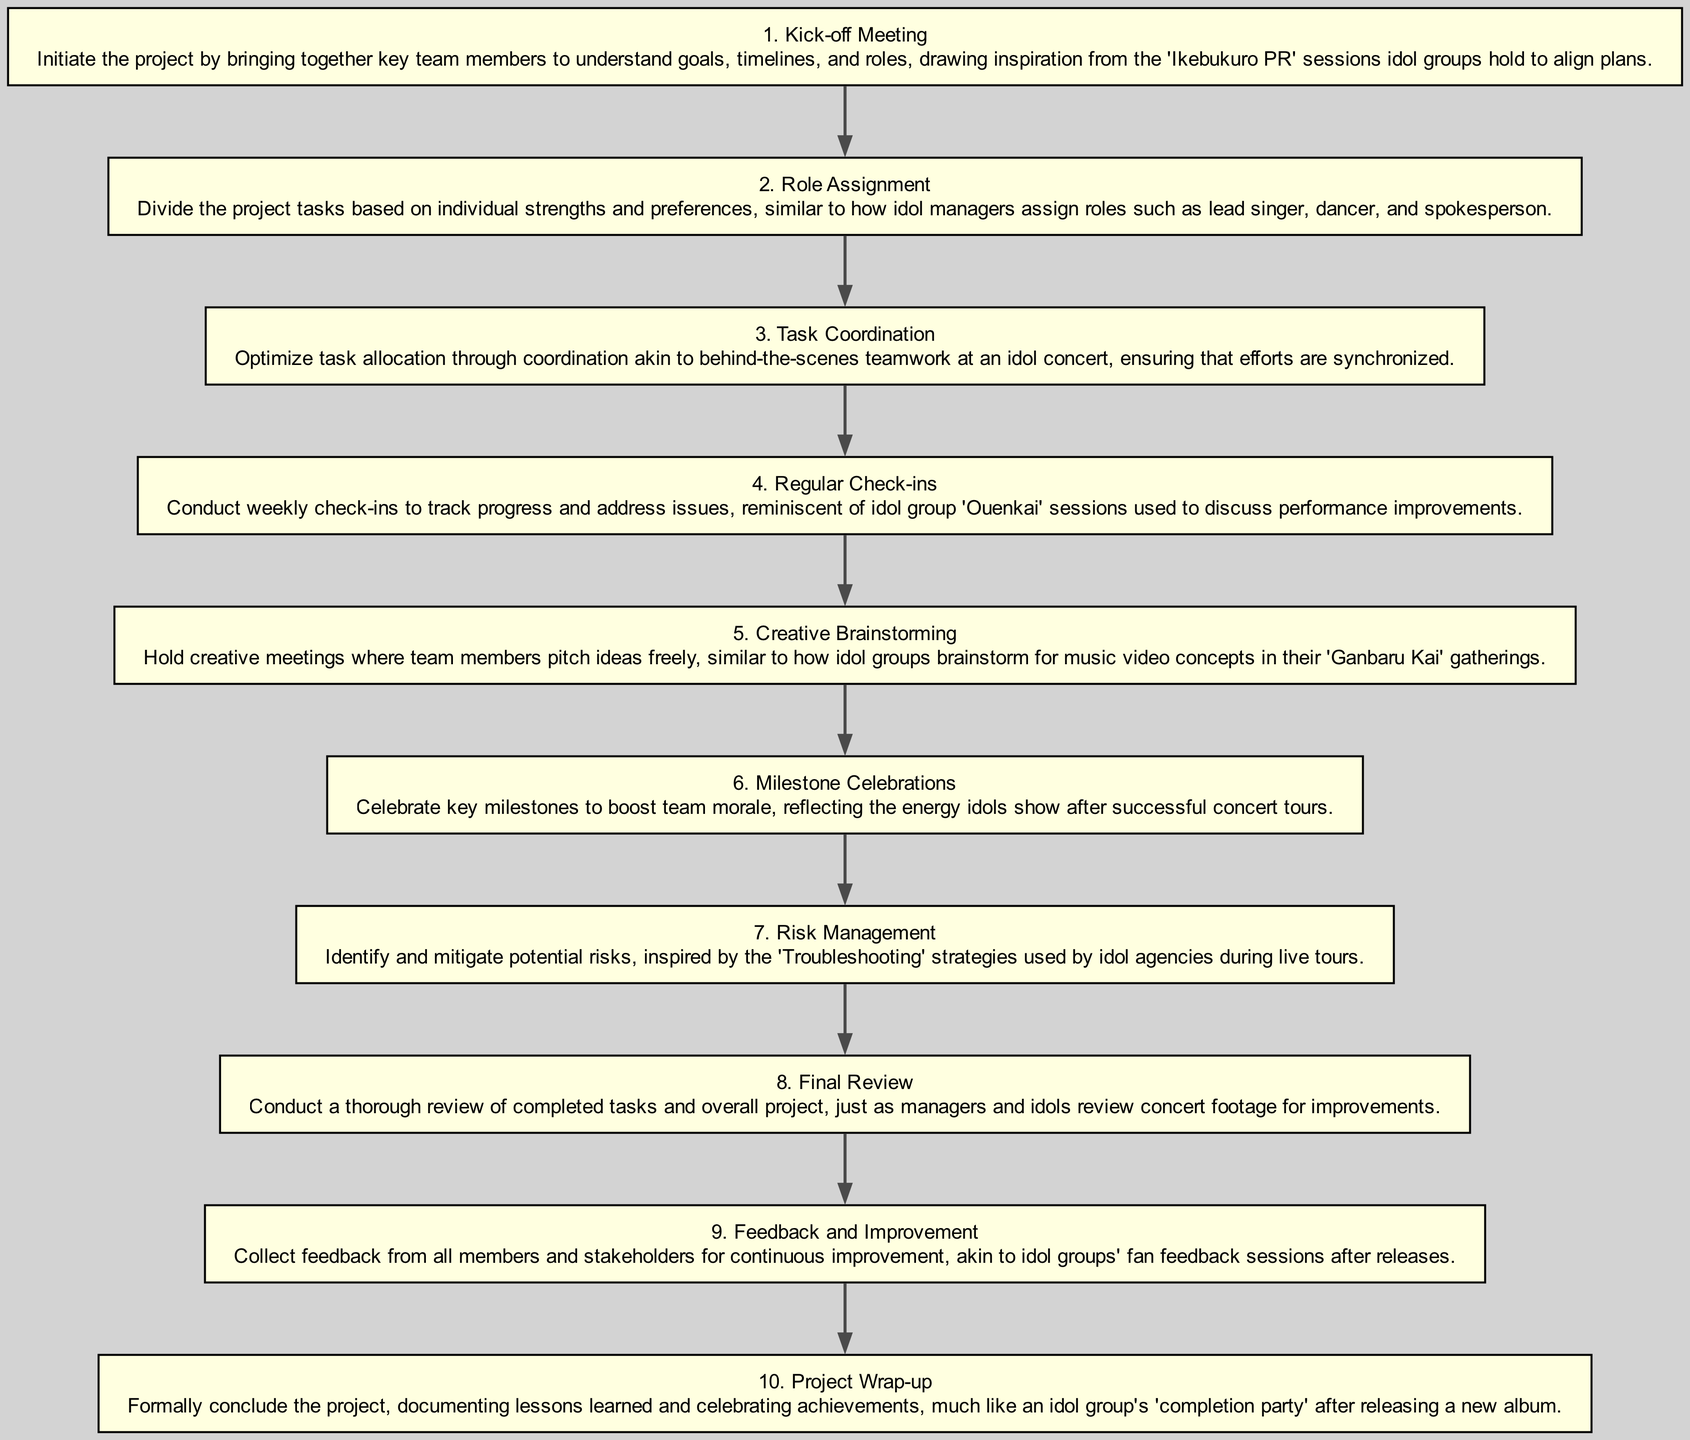What is the first step in the project management flow? The first step in the flow is identified by the label at the top of the diagram, which is "Kick-off Meeting." This is the first node outlined in the flow chart before any other steps.
Answer: Kick-off Meeting How many steps are included in the diagram? By counting the nodes represented in the diagram based on the data provided, there are a total of ten steps, as indicated by the sequential numbering from 1 to 10.
Answer: 10 Which step focuses on task allocation? The step that specifically addresses task allocation based on strengths and preferences is "Role Assignment." This is the second step in the sequence, indicating that after the initial meeting, roles are assigned accordingly.
Answer: Role Assignment What is the last step in the flow chart? The last step in the flow chart is depicted in the final node labeled "Project Wrap-up," which concludes the project management process as outlined.
Answer: Project Wrap-up What step involves celebrating key milestones? The step related to celebrating key milestones is labeled "Milestone Celebrations." This step focuses on boosting team morale and occurs after significant progress has been made in the project, indicated as step 6.
Answer: Milestone Celebrations What is the relationship between Regular Check-ins and Feedback and Improvement? The relationship between "Regular Check-ins" and "Feedback and Improvement" is that they are sequential steps in the project flow, where check-ins (step 4) help track progress leading into the feedback collection (step 9) for future improvements.
Answer: Sequential Which step is similar to idol groups' fan feedback sessions after releases? The step that is compared to idol groups' fan feedback sessions is labeled "Feedback and Improvement." This analogy emphasizes the importance of gathering feedback from team members, akin to how idols receive input from their fans.
Answer: Feedback and Improvement What is the common theme behind all steps in the diagram? The common theme unifying all the steps in the diagram is inspired by idol group dynamics, focusing on teamwork, organization, and synchronized efforts, as well as parallels drawn from idol culture practices throughout the project management process.
Answer: Idol group dynamics In which step do team members freely pitch ideas? The step where team members are encouraged to pitch ideas freely is "Creative Brainstorming." This is a collaborative gathering meant to promote creativity, mirroring the brainstorming sessions within idol groups for music videos.
Answer: Creative Brainstorming How does the flow chart highlight the importance of monitoring project progress? The flow chart highlights the importance of monitoring project progress through the inclusion of steps like "Regular Check-ins" which facilitate tracking advancements, and "Final Review" to assess overall project performance. This emphasizes continuous monitoring throughout the workflow.
Answer: Continuous monitoring 